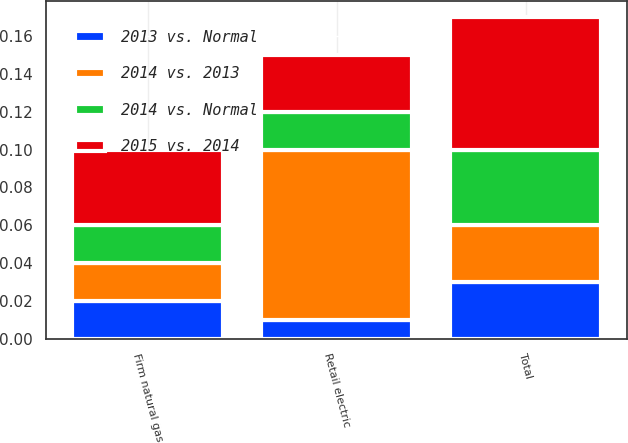Convert chart. <chart><loc_0><loc_0><loc_500><loc_500><stacked_bar_chart><ecel><fcel>Retail electric<fcel>Firm natural gas<fcel>Total<nl><fcel>2014 vs. Normal<fcel>0.02<fcel>0.02<fcel>0.04<nl><fcel>2013 vs. Normal<fcel>0.01<fcel>0.02<fcel>0.03<nl><fcel>2015 vs. 2014<fcel>0.03<fcel>0.04<fcel>0.07<nl><fcel>2014 vs. 2013<fcel>0.09<fcel>0.02<fcel>0.03<nl></chart> 